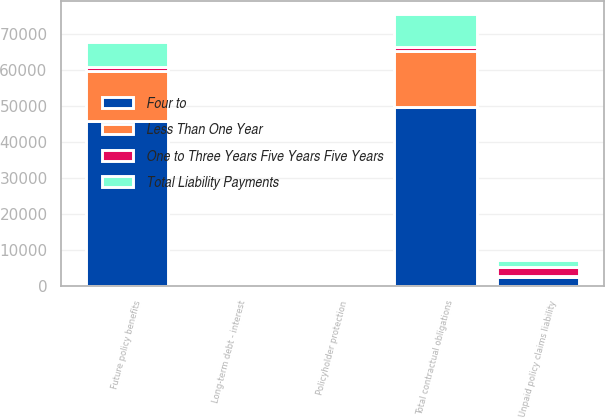Convert chart. <chart><loc_0><loc_0><loc_500><loc_500><stacked_bar_chart><ecel><fcel>Future policy benefits<fcel>Unpaid policy claims liability<fcel>Long-term debt - interest<fcel>Policyholder protection<fcel>Total contractual obligations<nl><fcel>Four to<fcel>45675<fcel>2455<fcel>5<fcel>151<fcel>49751<nl><fcel>One to Three Years Five Years Five Years<fcel>1114.5<fcel>2455<fcel>72<fcel>151<fcel>1114.5<nl><fcel>Total Liability Payments<fcel>7014<fcel>1866<fcel>22<fcel>23<fcel>9070<nl><fcel>Less Than One Year<fcel>13949<fcel>363<fcel>29<fcel>51<fcel>15409<nl></chart> 